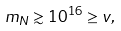Convert formula to latex. <formula><loc_0><loc_0><loc_500><loc_500>m _ { N } \gtrsim 1 0 ^ { 1 6 } \geq v ,</formula> 